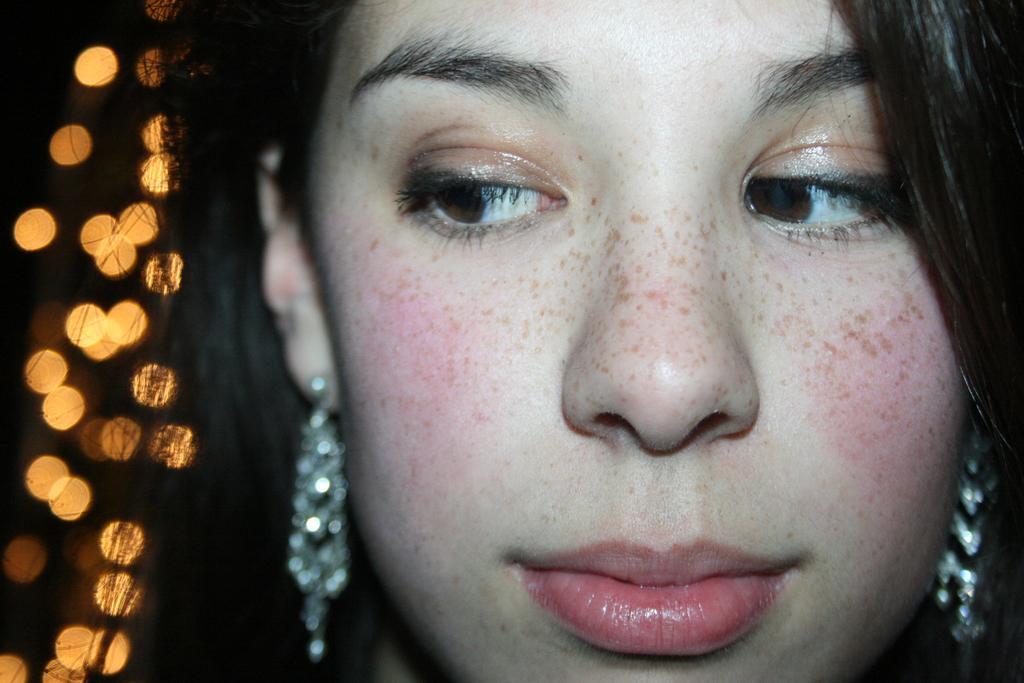How would you summarize this image in a sentence or two? In this image we can see womans face. In the background there are lights. 